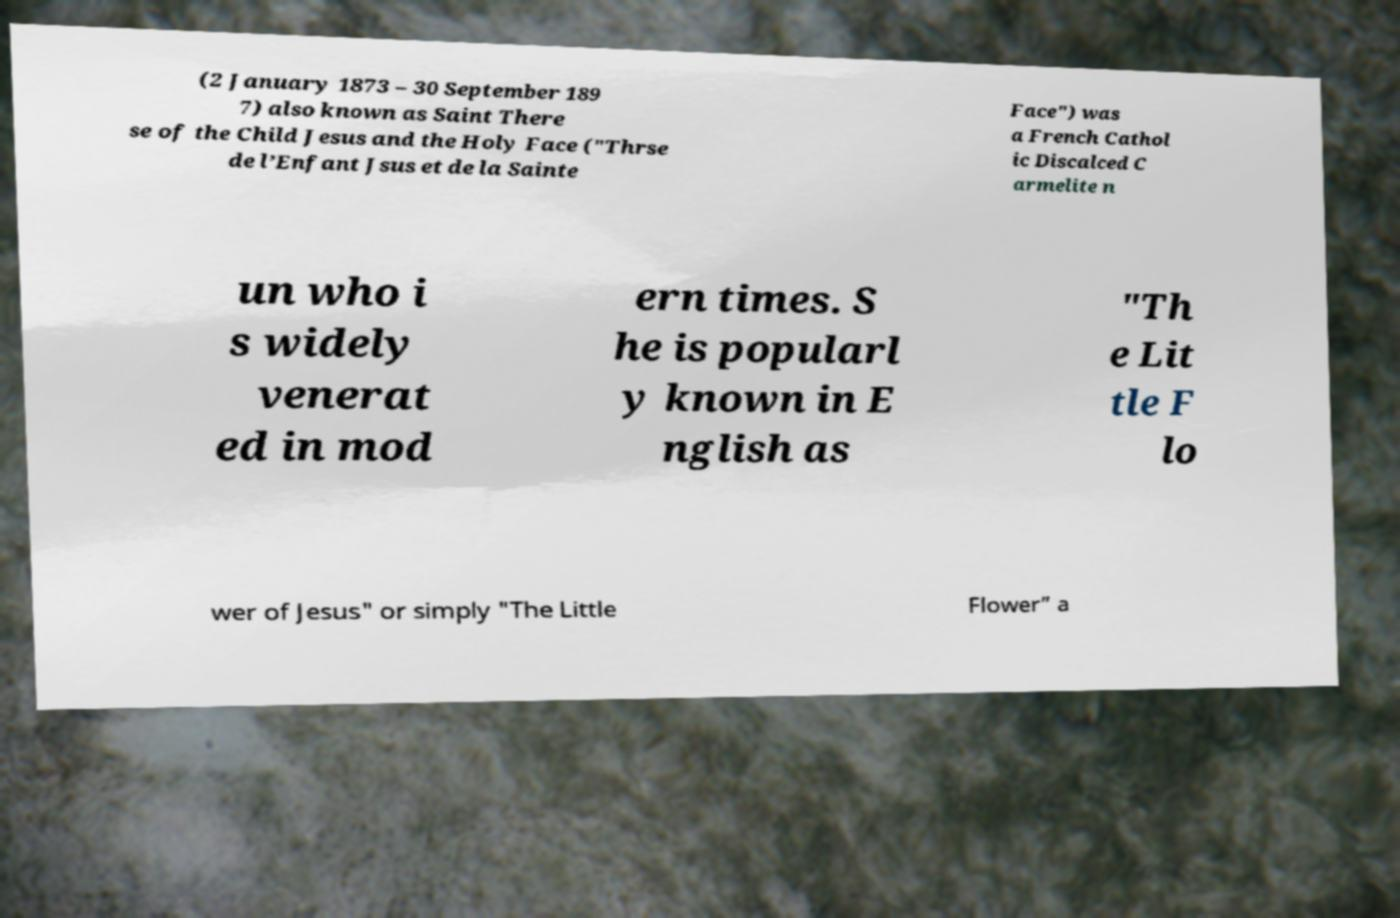Please read and relay the text visible in this image. What does it say? (2 January 1873 – 30 September 189 7) also known as Saint There se of the Child Jesus and the Holy Face ("Thrse de l’Enfant Jsus et de la Sainte Face") was a French Cathol ic Discalced C armelite n un who i s widely venerat ed in mod ern times. S he is popularl y known in E nglish as "Th e Lit tle F lo wer of Jesus" or simply "The Little Flower” a 